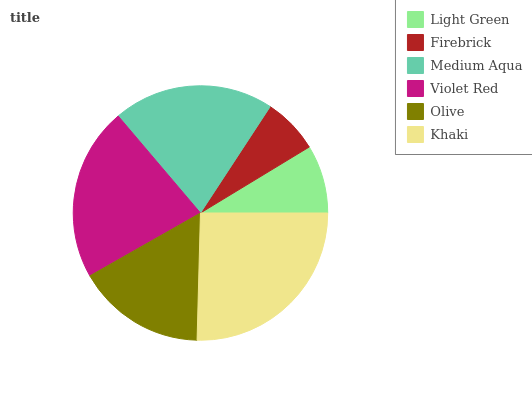Is Firebrick the minimum?
Answer yes or no. Yes. Is Khaki the maximum?
Answer yes or no. Yes. Is Medium Aqua the minimum?
Answer yes or no. No. Is Medium Aqua the maximum?
Answer yes or no. No. Is Medium Aqua greater than Firebrick?
Answer yes or no. Yes. Is Firebrick less than Medium Aqua?
Answer yes or no. Yes. Is Firebrick greater than Medium Aqua?
Answer yes or no. No. Is Medium Aqua less than Firebrick?
Answer yes or no. No. Is Medium Aqua the high median?
Answer yes or no. Yes. Is Olive the low median?
Answer yes or no. Yes. Is Firebrick the high median?
Answer yes or no. No. Is Khaki the low median?
Answer yes or no. No. 